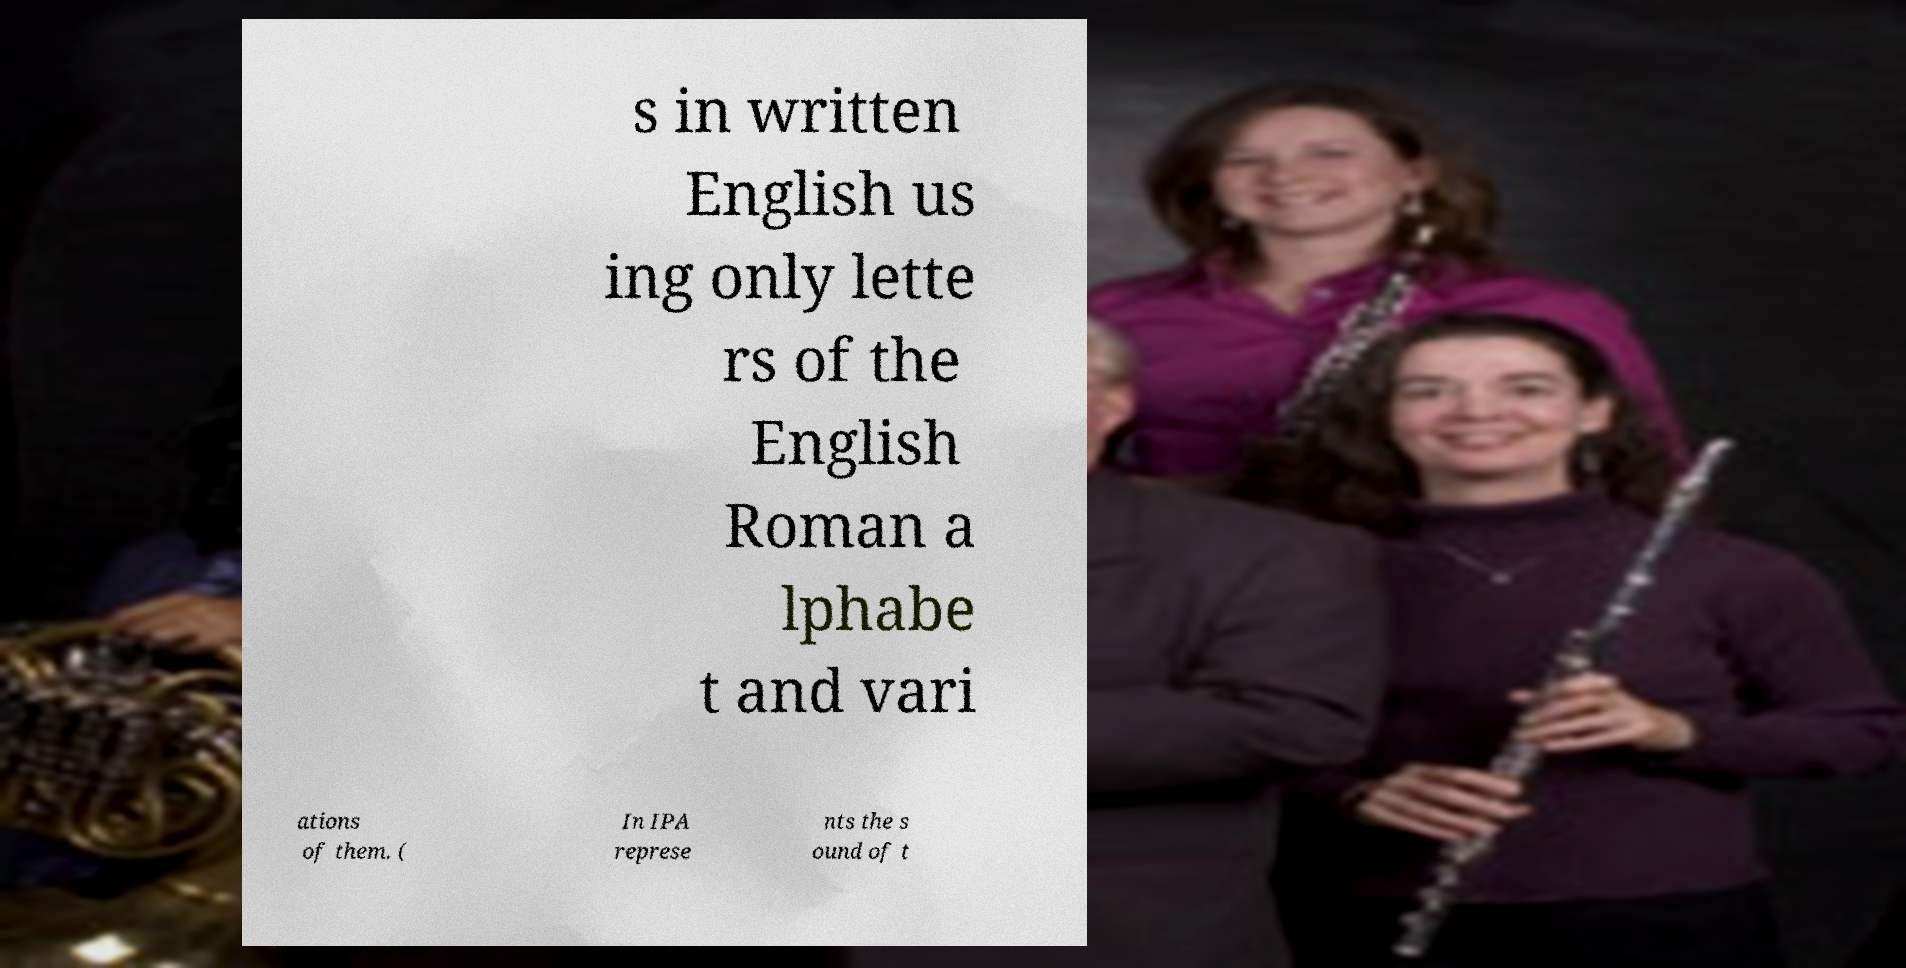For documentation purposes, I need the text within this image transcribed. Could you provide that? s in written English us ing only lette rs of the English Roman a lphabe t and vari ations of them. ( In IPA represe nts the s ound of t 